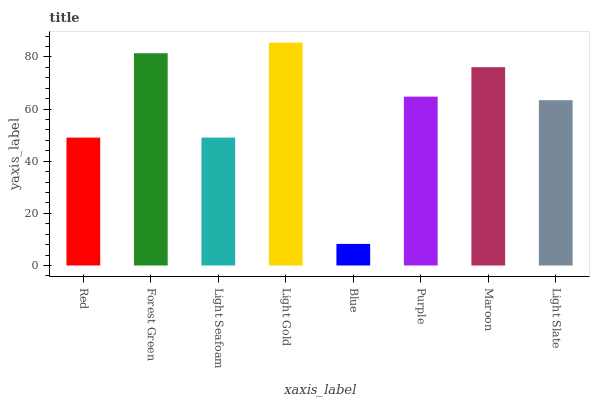Is Blue the minimum?
Answer yes or no. Yes. Is Light Gold the maximum?
Answer yes or no. Yes. Is Forest Green the minimum?
Answer yes or no. No. Is Forest Green the maximum?
Answer yes or no. No. Is Forest Green greater than Red?
Answer yes or no. Yes. Is Red less than Forest Green?
Answer yes or no. Yes. Is Red greater than Forest Green?
Answer yes or no. No. Is Forest Green less than Red?
Answer yes or no. No. Is Purple the high median?
Answer yes or no. Yes. Is Light Slate the low median?
Answer yes or no. Yes. Is Maroon the high median?
Answer yes or no. No. Is Red the low median?
Answer yes or no. No. 